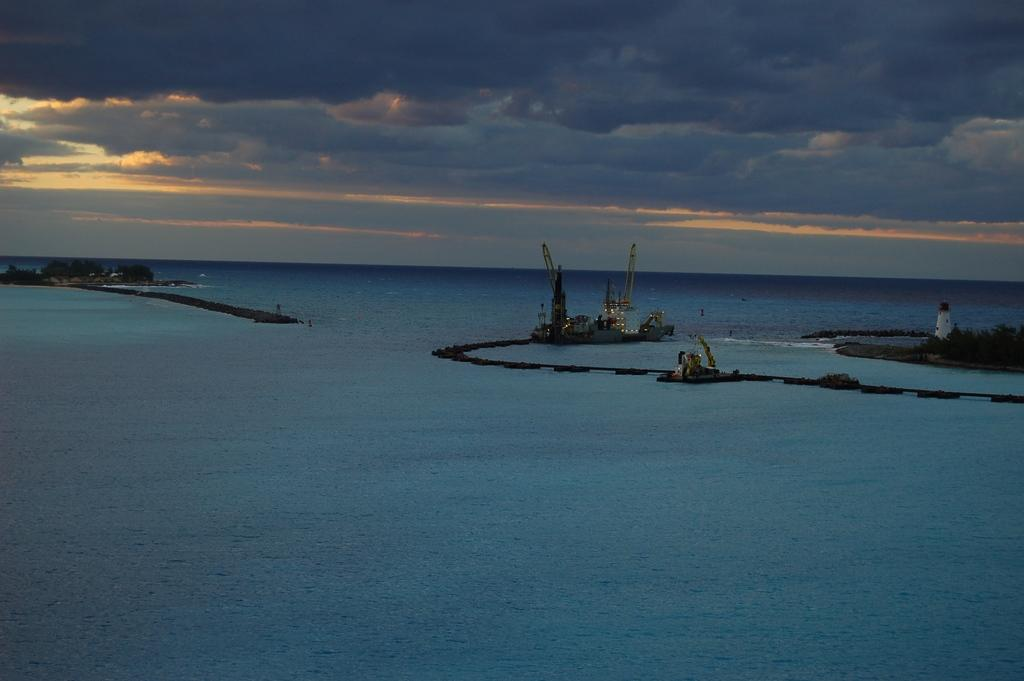What is the main subject of the picture? The main subject of the picture is water. What else can be seen in the water? There is a ship and a boat in the picture. What is visible above the water? The sky is visible in the picture. How does the daughter react to the harbor in the image? There is no daughter present in the image, and therefore no reaction can be observed. 